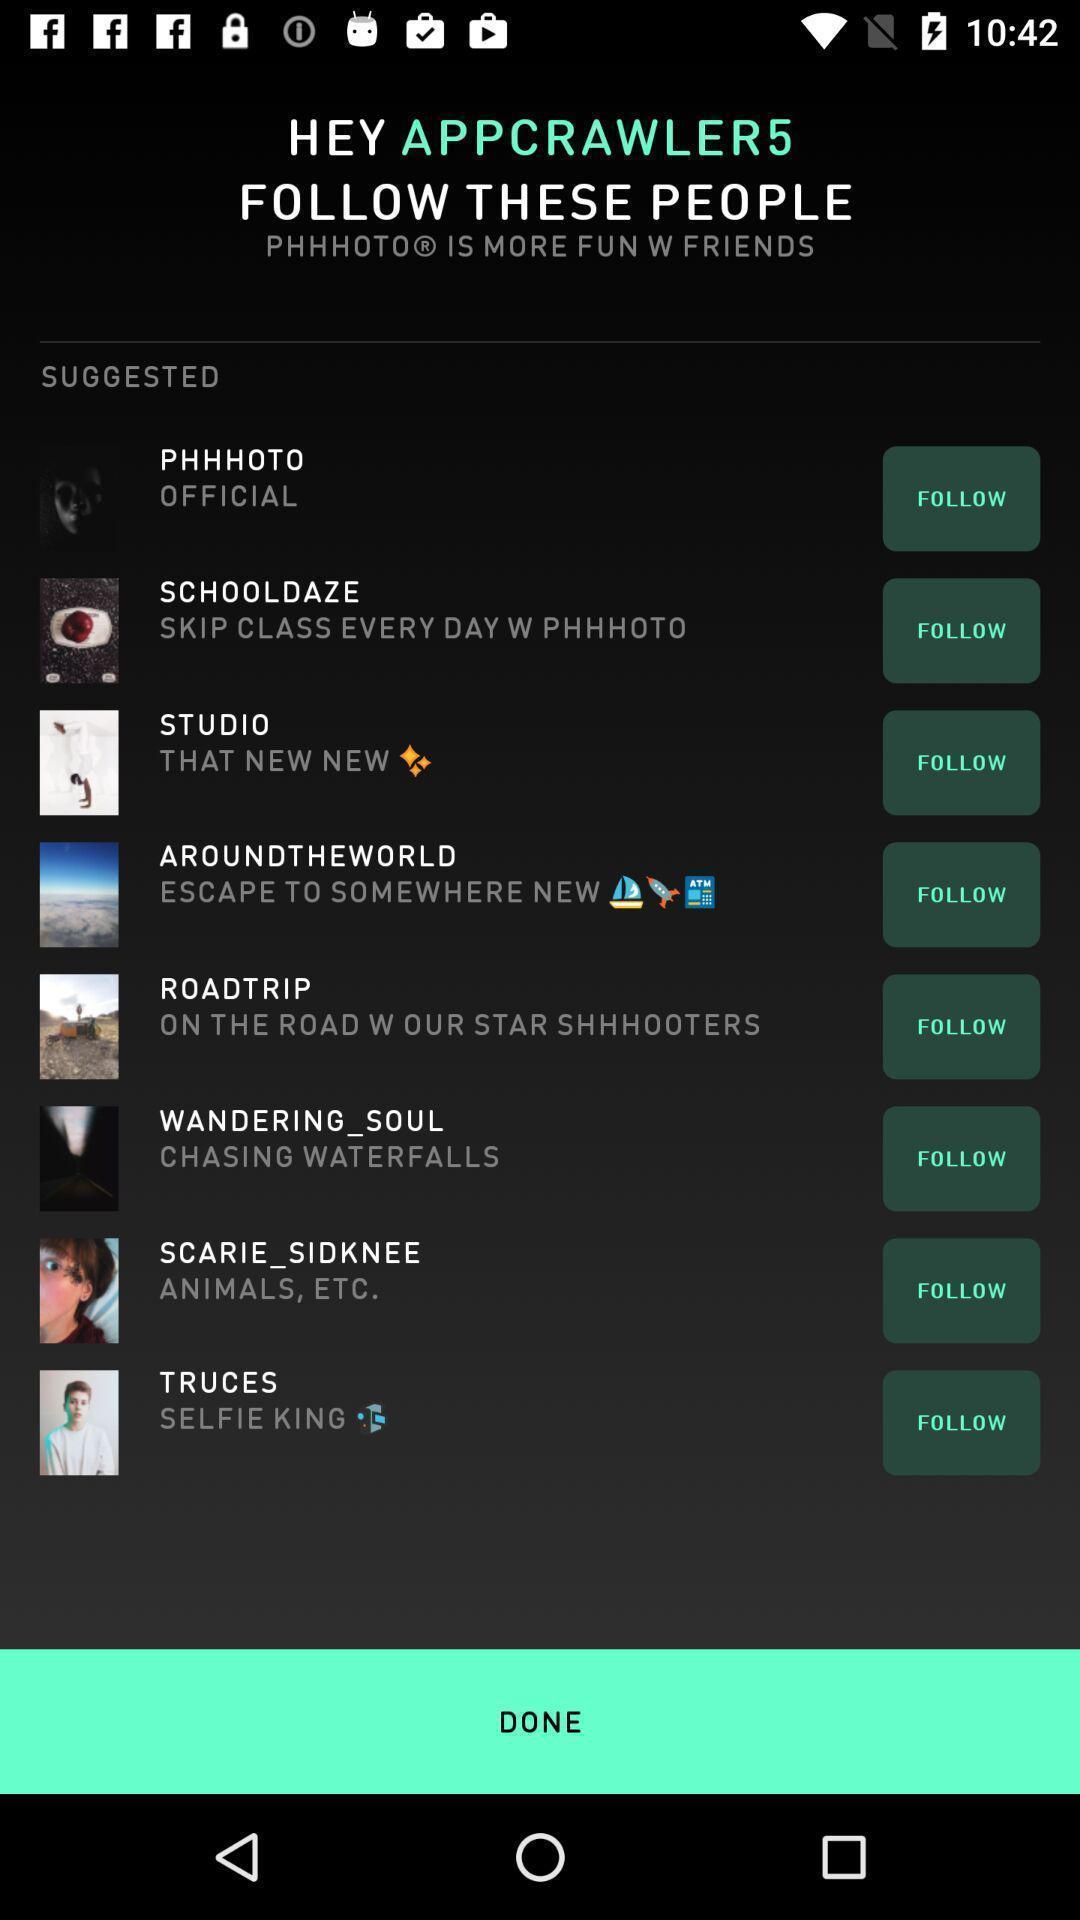Describe the visual elements of this screenshot. Screen displaying page of an social application. 